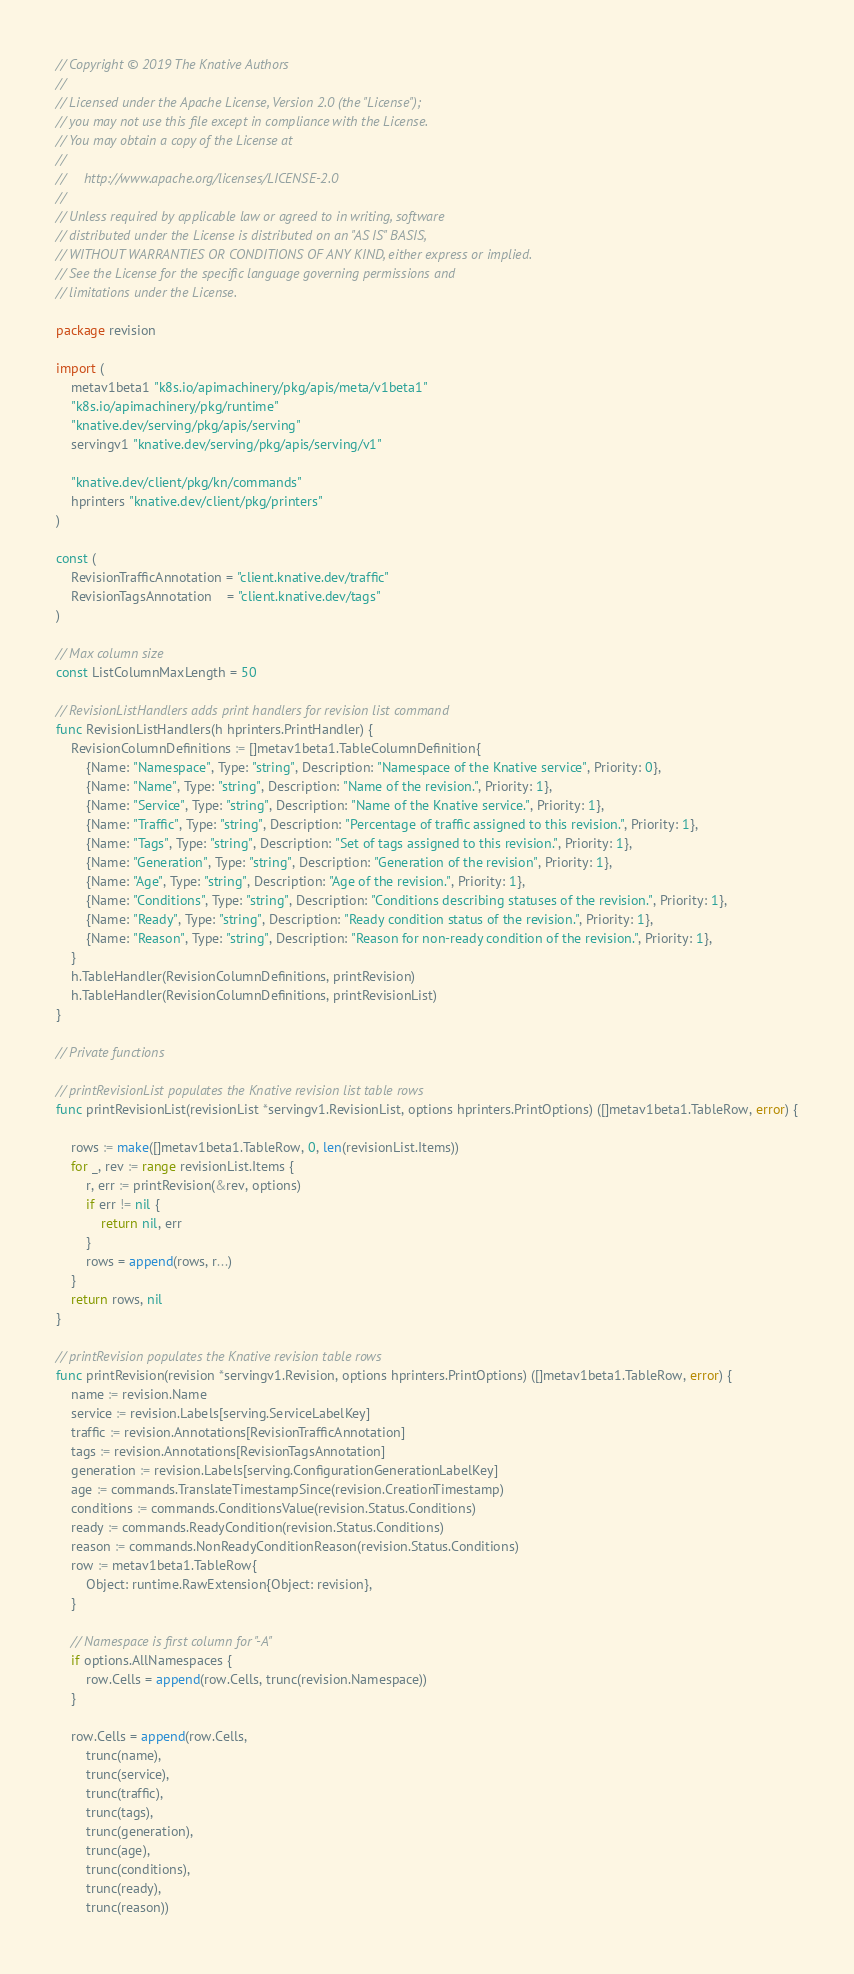Convert code to text. <code><loc_0><loc_0><loc_500><loc_500><_Go_>// Copyright © 2019 The Knative Authors
//
// Licensed under the Apache License, Version 2.0 (the "License");
// you may not use this file except in compliance with the License.
// You may obtain a copy of the License at
//
//     http://www.apache.org/licenses/LICENSE-2.0
//
// Unless required by applicable law or agreed to in writing, software
// distributed under the License is distributed on an "AS IS" BASIS,
// WITHOUT WARRANTIES OR CONDITIONS OF ANY KIND, either express or implied.
// See the License for the specific language governing permissions and
// limitations under the License.

package revision

import (
	metav1beta1 "k8s.io/apimachinery/pkg/apis/meta/v1beta1"
	"k8s.io/apimachinery/pkg/runtime"
	"knative.dev/serving/pkg/apis/serving"
	servingv1 "knative.dev/serving/pkg/apis/serving/v1"

	"knative.dev/client/pkg/kn/commands"
	hprinters "knative.dev/client/pkg/printers"
)

const (
	RevisionTrafficAnnotation = "client.knative.dev/traffic"
	RevisionTagsAnnotation    = "client.knative.dev/tags"
)

// Max column size
const ListColumnMaxLength = 50

// RevisionListHandlers adds print handlers for revision list command
func RevisionListHandlers(h hprinters.PrintHandler) {
	RevisionColumnDefinitions := []metav1beta1.TableColumnDefinition{
		{Name: "Namespace", Type: "string", Description: "Namespace of the Knative service", Priority: 0},
		{Name: "Name", Type: "string", Description: "Name of the revision.", Priority: 1},
		{Name: "Service", Type: "string", Description: "Name of the Knative service.", Priority: 1},
		{Name: "Traffic", Type: "string", Description: "Percentage of traffic assigned to this revision.", Priority: 1},
		{Name: "Tags", Type: "string", Description: "Set of tags assigned to this revision.", Priority: 1},
		{Name: "Generation", Type: "string", Description: "Generation of the revision", Priority: 1},
		{Name: "Age", Type: "string", Description: "Age of the revision.", Priority: 1},
		{Name: "Conditions", Type: "string", Description: "Conditions describing statuses of the revision.", Priority: 1},
		{Name: "Ready", Type: "string", Description: "Ready condition status of the revision.", Priority: 1},
		{Name: "Reason", Type: "string", Description: "Reason for non-ready condition of the revision.", Priority: 1},
	}
	h.TableHandler(RevisionColumnDefinitions, printRevision)
	h.TableHandler(RevisionColumnDefinitions, printRevisionList)
}

// Private functions

// printRevisionList populates the Knative revision list table rows
func printRevisionList(revisionList *servingv1.RevisionList, options hprinters.PrintOptions) ([]metav1beta1.TableRow, error) {

	rows := make([]metav1beta1.TableRow, 0, len(revisionList.Items))
	for _, rev := range revisionList.Items {
		r, err := printRevision(&rev, options)
		if err != nil {
			return nil, err
		}
		rows = append(rows, r...)
	}
	return rows, nil
}

// printRevision populates the Knative revision table rows
func printRevision(revision *servingv1.Revision, options hprinters.PrintOptions) ([]metav1beta1.TableRow, error) {
	name := revision.Name
	service := revision.Labels[serving.ServiceLabelKey]
	traffic := revision.Annotations[RevisionTrafficAnnotation]
	tags := revision.Annotations[RevisionTagsAnnotation]
	generation := revision.Labels[serving.ConfigurationGenerationLabelKey]
	age := commands.TranslateTimestampSince(revision.CreationTimestamp)
	conditions := commands.ConditionsValue(revision.Status.Conditions)
	ready := commands.ReadyCondition(revision.Status.Conditions)
	reason := commands.NonReadyConditionReason(revision.Status.Conditions)
	row := metav1beta1.TableRow{
		Object: runtime.RawExtension{Object: revision},
	}

	// Namespace is first column for "-A"
	if options.AllNamespaces {
		row.Cells = append(row.Cells, trunc(revision.Namespace))
	}

	row.Cells = append(row.Cells,
		trunc(name),
		trunc(service),
		trunc(traffic),
		trunc(tags),
		trunc(generation),
		trunc(age),
		trunc(conditions),
		trunc(ready),
		trunc(reason))</code> 